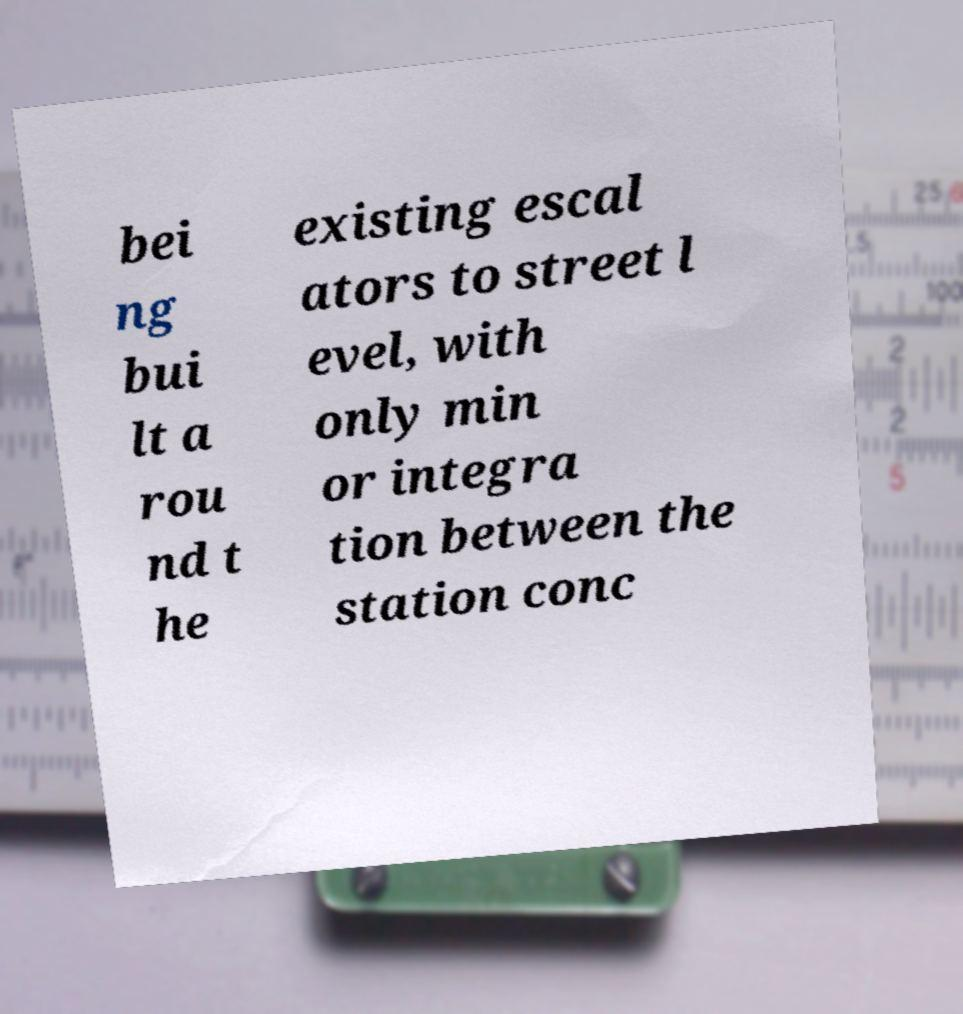There's text embedded in this image that I need extracted. Can you transcribe it verbatim? bei ng bui lt a rou nd t he existing escal ators to street l evel, with only min or integra tion between the station conc 